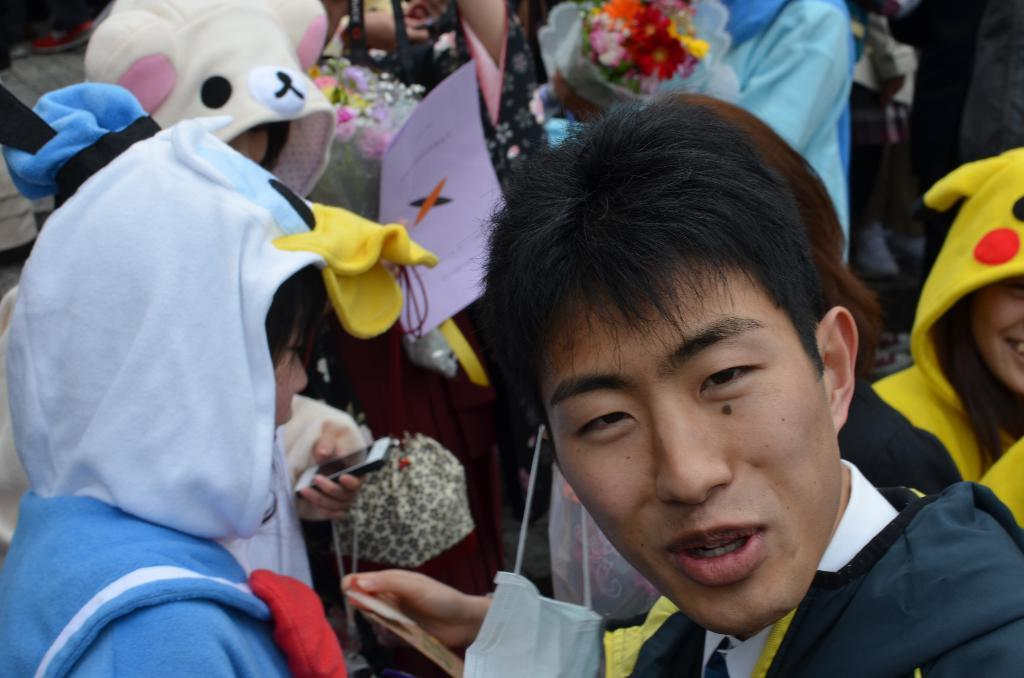Who or what can be seen in the image? There are people in the image. What type of plants are visible in the image? There are flowers in the image. What material is present in the image? There is paper in the image. What object is one person holding in the image? One person is holding a mobile in the image. What type of pear is being used as a prop in the image? There is no pear present in the image. What channel is being watched by the people in the image? There is no reference to a television or any channel in the image. 